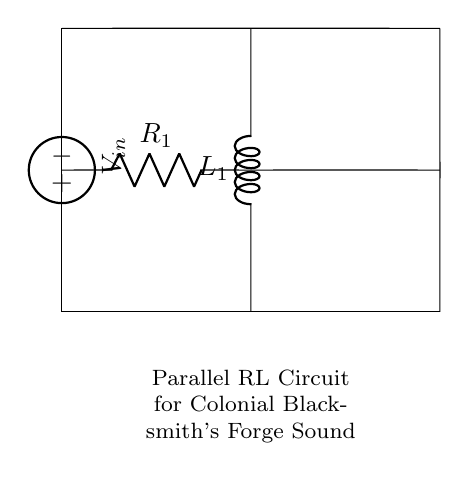What is the value of the resistor in this circuit? The value of the resistor is indicated by the label R1 on the circuit diagram. Since the value is not specified in the diagram, it's dependent on the circuit design but is typically given in ohms.
Answer: R1 What type of circuit is represented here? The circuit consists of a resistor and inductor connected in parallel, as indicated by the layout and configuration of the components. This specific arrangement categorizes the circuit as a parallel RL circuit.
Answer: Parallel RL circuit What does the voltage source represent? The voltage source labeled V_in provides the potential difference required to drive current through the circuit. This is critical for the operation of both the resistor and inductor within the circuit.
Answer: V_in How many inductors are present in this circuit? The circuit diagram clearly shows a single inductor labeled L1, indicating there is only one inductor in this parallel configuration.
Answer: One What is the function of the resistor in this circuit? The resistor in this parallel RL circuit limits the current flow and dissipates energy in the form of heat. Its presence affects the overall impedance of the circuit and influences the sound output.
Answer: Limit current What impact does the inductor have on the sound produced? The inductor's presence adds inductance to the circuit, which impacts the timing response and can create a resonating effect, simulating the sound characteristics of a blacksmith's forge, such as a humming or buzzing sound.
Answer: Resonating effect What can be inferred about the current through the components? In a parallel circuit, the voltage across each component is the same (V_in). Therefore, the current through each component (R1 and L1) can be different, adhering to Ohm's law for the resistor and responding to the rate of change of current for the inductor.
Answer: Varies through components 